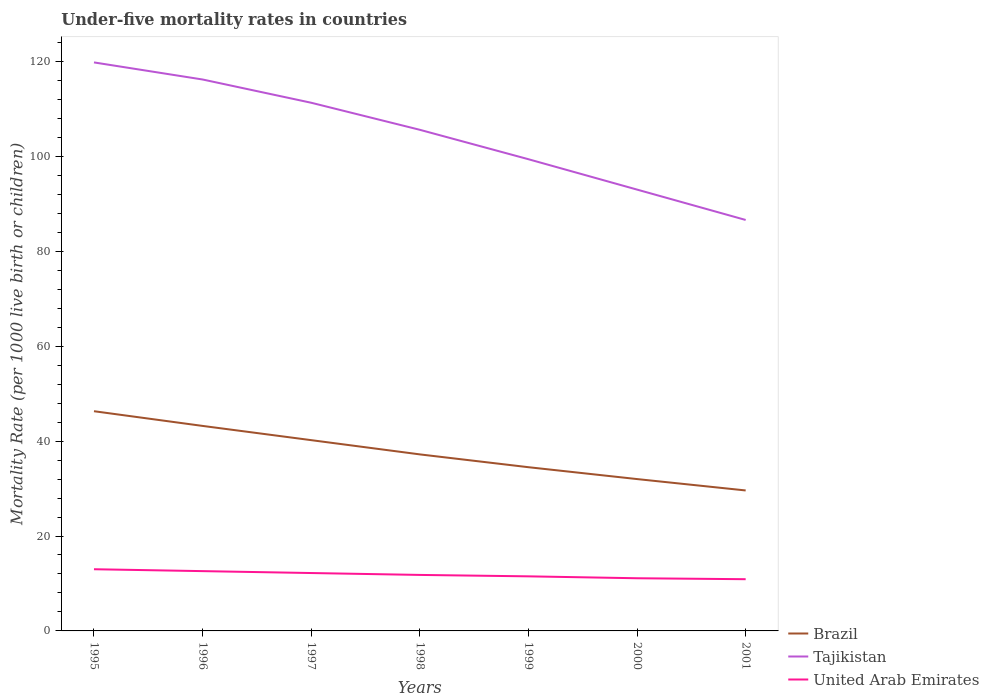Across all years, what is the maximum under-five mortality rate in United Arab Emirates?
Provide a short and direct response. 10.9. What is the total under-five mortality rate in Brazil in the graph?
Provide a succinct answer. 8.7. What is the difference between the highest and the second highest under-five mortality rate in United Arab Emirates?
Your response must be concise. 2.1. What is the difference between the highest and the lowest under-five mortality rate in United Arab Emirates?
Provide a short and direct response. 3. How many years are there in the graph?
Offer a terse response. 7. What is the difference between two consecutive major ticks on the Y-axis?
Offer a terse response. 20. Are the values on the major ticks of Y-axis written in scientific E-notation?
Ensure brevity in your answer.  No. Where does the legend appear in the graph?
Ensure brevity in your answer.  Bottom right. What is the title of the graph?
Ensure brevity in your answer.  Under-five mortality rates in countries. What is the label or title of the Y-axis?
Keep it short and to the point. Mortality Rate (per 1000 live birth or children). What is the Mortality Rate (per 1000 live birth or children) in Brazil in 1995?
Offer a terse response. 46.3. What is the Mortality Rate (per 1000 live birth or children) in Tajikistan in 1995?
Offer a very short reply. 119.8. What is the Mortality Rate (per 1000 live birth or children) of United Arab Emirates in 1995?
Ensure brevity in your answer.  13. What is the Mortality Rate (per 1000 live birth or children) in Brazil in 1996?
Keep it short and to the point. 43.2. What is the Mortality Rate (per 1000 live birth or children) in Tajikistan in 1996?
Ensure brevity in your answer.  116.2. What is the Mortality Rate (per 1000 live birth or children) in United Arab Emirates in 1996?
Provide a short and direct response. 12.6. What is the Mortality Rate (per 1000 live birth or children) of Brazil in 1997?
Your answer should be very brief. 40.2. What is the Mortality Rate (per 1000 live birth or children) of Tajikistan in 1997?
Keep it short and to the point. 111.3. What is the Mortality Rate (per 1000 live birth or children) of United Arab Emirates in 1997?
Your answer should be very brief. 12.2. What is the Mortality Rate (per 1000 live birth or children) of Brazil in 1998?
Provide a succinct answer. 37.2. What is the Mortality Rate (per 1000 live birth or children) of Tajikistan in 1998?
Ensure brevity in your answer.  105.6. What is the Mortality Rate (per 1000 live birth or children) in Brazil in 1999?
Your answer should be compact. 34.5. What is the Mortality Rate (per 1000 live birth or children) in Tajikistan in 1999?
Keep it short and to the point. 99.4. What is the Mortality Rate (per 1000 live birth or children) in United Arab Emirates in 1999?
Your answer should be compact. 11.5. What is the Mortality Rate (per 1000 live birth or children) in Tajikistan in 2000?
Provide a short and direct response. 93. What is the Mortality Rate (per 1000 live birth or children) in Brazil in 2001?
Provide a short and direct response. 29.6. What is the Mortality Rate (per 1000 live birth or children) in Tajikistan in 2001?
Offer a terse response. 86.6. What is the Mortality Rate (per 1000 live birth or children) of United Arab Emirates in 2001?
Ensure brevity in your answer.  10.9. Across all years, what is the maximum Mortality Rate (per 1000 live birth or children) of Brazil?
Ensure brevity in your answer.  46.3. Across all years, what is the maximum Mortality Rate (per 1000 live birth or children) in Tajikistan?
Keep it short and to the point. 119.8. Across all years, what is the maximum Mortality Rate (per 1000 live birth or children) in United Arab Emirates?
Your answer should be very brief. 13. Across all years, what is the minimum Mortality Rate (per 1000 live birth or children) in Brazil?
Give a very brief answer. 29.6. Across all years, what is the minimum Mortality Rate (per 1000 live birth or children) of Tajikistan?
Offer a very short reply. 86.6. Across all years, what is the minimum Mortality Rate (per 1000 live birth or children) in United Arab Emirates?
Offer a very short reply. 10.9. What is the total Mortality Rate (per 1000 live birth or children) in Brazil in the graph?
Your answer should be very brief. 263. What is the total Mortality Rate (per 1000 live birth or children) of Tajikistan in the graph?
Ensure brevity in your answer.  731.9. What is the total Mortality Rate (per 1000 live birth or children) in United Arab Emirates in the graph?
Provide a succinct answer. 83.1. What is the difference between the Mortality Rate (per 1000 live birth or children) in Brazil in 1995 and that in 1996?
Give a very brief answer. 3.1. What is the difference between the Mortality Rate (per 1000 live birth or children) in United Arab Emirates in 1995 and that in 1996?
Make the answer very short. 0.4. What is the difference between the Mortality Rate (per 1000 live birth or children) in United Arab Emirates in 1995 and that in 1997?
Ensure brevity in your answer.  0.8. What is the difference between the Mortality Rate (per 1000 live birth or children) of Brazil in 1995 and that in 1998?
Offer a terse response. 9.1. What is the difference between the Mortality Rate (per 1000 live birth or children) in Brazil in 1995 and that in 1999?
Offer a terse response. 11.8. What is the difference between the Mortality Rate (per 1000 live birth or children) in Tajikistan in 1995 and that in 1999?
Keep it short and to the point. 20.4. What is the difference between the Mortality Rate (per 1000 live birth or children) in United Arab Emirates in 1995 and that in 1999?
Keep it short and to the point. 1.5. What is the difference between the Mortality Rate (per 1000 live birth or children) of Brazil in 1995 and that in 2000?
Provide a succinct answer. 14.3. What is the difference between the Mortality Rate (per 1000 live birth or children) of Tajikistan in 1995 and that in 2000?
Offer a terse response. 26.8. What is the difference between the Mortality Rate (per 1000 live birth or children) of Brazil in 1995 and that in 2001?
Make the answer very short. 16.7. What is the difference between the Mortality Rate (per 1000 live birth or children) of Tajikistan in 1995 and that in 2001?
Offer a very short reply. 33.2. What is the difference between the Mortality Rate (per 1000 live birth or children) in United Arab Emirates in 1995 and that in 2001?
Provide a short and direct response. 2.1. What is the difference between the Mortality Rate (per 1000 live birth or children) in United Arab Emirates in 1996 and that in 1998?
Your response must be concise. 0.8. What is the difference between the Mortality Rate (per 1000 live birth or children) of Brazil in 1996 and that in 1999?
Your answer should be compact. 8.7. What is the difference between the Mortality Rate (per 1000 live birth or children) of Tajikistan in 1996 and that in 1999?
Your response must be concise. 16.8. What is the difference between the Mortality Rate (per 1000 live birth or children) of United Arab Emirates in 1996 and that in 1999?
Provide a short and direct response. 1.1. What is the difference between the Mortality Rate (per 1000 live birth or children) of Tajikistan in 1996 and that in 2000?
Your answer should be very brief. 23.2. What is the difference between the Mortality Rate (per 1000 live birth or children) in Tajikistan in 1996 and that in 2001?
Keep it short and to the point. 29.6. What is the difference between the Mortality Rate (per 1000 live birth or children) in United Arab Emirates in 1997 and that in 1998?
Provide a succinct answer. 0.4. What is the difference between the Mortality Rate (per 1000 live birth or children) in United Arab Emirates in 1997 and that in 1999?
Ensure brevity in your answer.  0.7. What is the difference between the Mortality Rate (per 1000 live birth or children) in Tajikistan in 1997 and that in 2000?
Provide a succinct answer. 18.3. What is the difference between the Mortality Rate (per 1000 live birth or children) of United Arab Emirates in 1997 and that in 2000?
Your answer should be compact. 1.1. What is the difference between the Mortality Rate (per 1000 live birth or children) in Tajikistan in 1997 and that in 2001?
Give a very brief answer. 24.7. What is the difference between the Mortality Rate (per 1000 live birth or children) in United Arab Emirates in 1997 and that in 2001?
Your answer should be very brief. 1.3. What is the difference between the Mortality Rate (per 1000 live birth or children) in Brazil in 1998 and that in 1999?
Your answer should be very brief. 2.7. What is the difference between the Mortality Rate (per 1000 live birth or children) of United Arab Emirates in 1998 and that in 2000?
Provide a short and direct response. 0.7. What is the difference between the Mortality Rate (per 1000 live birth or children) in Tajikistan in 1998 and that in 2001?
Your answer should be very brief. 19. What is the difference between the Mortality Rate (per 1000 live birth or children) of United Arab Emirates in 1998 and that in 2001?
Keep it short and to the point. 0.9. What is the difference between the Mortality Rate (per 1000 live birth or children) of Brazil in 1999 and that in 2000?
Your response must be concise. 2.5. What is the difference between the Mortality Rate (per 1000 live birth or children) in Tajikistan in 1999 and that in 2000?
Offer a terse response. 6.4. What is the difference between the Mortality Rate (per 1000 live birth or children) of United Arab Emirates in 1999 and that in 2000?
Keep it short and to the point. 0.4. What is the difference between the Mortality Rate (per 1000 live birth or children) in Brazil in 1999 and that in 2001?
Make the answer very short. 4.9. What is the difference between the Mortality Rate (per 1000 live birth or children) in Tajikistan in 1999 and that in 2001?
Your response must be concise. 12.8. What is the difference between the Mortality Rate (per 1000 live birth or children) in United Arab Emirates in 1999 and that in 2001?
Keep it short and to the point. 0.6. What is the difference between the Mortality Rate (per 1000 live birth or children) in Tajikistan in 2000 and that in 2001?
Give a very brief answer. 6.4. What is the difference between the Mortality Rate (per 1000 live birth or children) of United Arab Emirates in 2000 and that in 2001?
Offer a very short reply. 0.2. What is the difference between the Mortality Rate (per 1000 live birth or children) of Brazil in 1995 and the Mortality Rate (per 1000 live birth or children) of Tajikistan in 1996?
Provide a succinct answer. -69.9. What is the difference between the Mortality Rate (per 1000 live birth or children) of Brazil in 1995 and the Mortality Rate (per 1000 live birth or children) of United Arab Emirates in 1996?
Provide a succinct answer. 33.7. What is the difference between the Mortality Rate (per 1000 live birth or children) in Tajikistan in 1995 and the Mortality Rate (per 1000 live birth or children) in United Arab Emirates in 1996?
Keep it short and to the point. 107.2. What is the difference between the Mortality Rate (per 1000 live birth or children) of Brazil in 1995 and the Mortality Rate (per 1000 live birth or children) of Tajikistan in 1997?
Make the answer very short. -65. What is the difference between the Mortality Rate (per 1000 live birth or children) in Brazil in 1995 and the Mortality Rate (per 1000 live birth or children) in United Arab Emirates in 1997?
Make the answer very short. 34.1. What is the difference between the Mortality Rate (per 1000 live birth or children) of Tajikistan in 1995 and the Mortality Rate (per 1000 live birth or children) of United Arab Emirates in 1997?
Your response must be concise. 107.6. What is the difference between the Mortality Rate (per 1000 live birth or children) in Brazil in 1995 and the Mortality Rate (per 1000 live birth or children) in Tajikistan in 1998?
Make the answer very short. -59.3. What is the difference between the Mortality Rate (per 1000 live birth or children) of Brazil in 1995 and the Mortality Rate (per 1000 live birth or children) of United Arab Emirates in 1998?
Provide a short and direct response. 34.5. What is the difference between the Mortality Rate (per 1000 live birth or children) of Tajikistan in 1995 and the Mortality Rate (per 1000 live birth or children) of United Arab Emirates in 1998?
Provide a succinct answer. 108. What is the difference between the Mortality Rate (per 1000 live birth or children) in Brazil in 1995 and the Mortality Rate (per 1000 live birth or children) in Tajikistan in 1999?
Make the answer very short. -53.1. What is the difference between the Mortality Rate (per 1000 live birth or children) in Brazil in 1995 and the Mortality Rate (per 1000 live birth or children) in United Arab Emirates in 1999?
Offer a very short reply. 34.8. What is the difference between the Mortality Rate (per 1000 live birth or children) in Tajikistan in 1995 and the Mortality Rate (per 1000 live birth or children) in United Arab Emirates in 1999?
Your response must be concise. 108.3. What is the difference between the Mortality Rate (per 1000 live birth or children) in Brazil in 1995 and the Mortality Rate (per 1000 live birth or children) in Tajikistan in 2000?
Give a very brief answer. -46.7. What is the difference between the Mortality Rate (per 1000 live birth or children) of Brazil in 1995 and the Mortality Rate (per 1000 live birth or children) of United Arab Emirates in 2000?
Offer a terse response. 35.2. What is the difference between the Mortality Rate (per 1000 live birth or children) of Tajikistan in 1995 and the Mortality Rate (per 1000 live birth or children) of United Arab Emirates in 2000?
Ensure brevity in your answer.  108.7. What is the difference between the Mortality Rate (per 1000 live birth or children) of Brazil in 1995 and the Mortality Rate (per 1000 live birth or children) of Tajikistan in 2001?
Keep it short and to the point. -40.3. What is the difference between the Mortality Rate (per 1000 live birth or children) of Brazil in 1995 and the Mortality Rate (per 1000 live birth or children) of United Arab Emirates in 2001?
Your response must be concise. 35.4. What is the difference between the Mortality Rate (per 1000 live birth or children) in Tajikistan in 1995 and the Mortality Rate (per 1000 live birth or children) in United Arab Emirates in 2001?
Make the answer very short. 108.9. What is the difference between the Mortality Rate (per 1000 live birth or children) of Brazil in 1996 and the Mortality Rate (per 1000 live birth or children) of Tajikistan in 1997?
Ensure brevity in your answer.  -68.1. What is the difference between the Mortality Rate (per 1000 live birth or children) of Tajikistan in 1996 and the Mortality Rate (per 1000 live birth or children) of United Arab Emirates in 1997?
Keep it short and to the point. 104. What is the difference between the Mortality Rate (per 1000 live birth or children) in Brazil in 1996 and the Mortality Rate (per 1000 live birth or children) in Tajikistan in 1998?
Provide a short and direct response. -62.4. What is the difference between the Mortality Rate (per 1000 live birth or children) in Brazil in 1996 and the Mortality Rate (per 1000 live birth or children) in United Arab Emirates in 1998?
Offer a terse response. 31.4. What is the difference between the Mortality Rate (per 1000 live birth or children) in Tajikistan in 1996 and the Mortality Rate (per 1000 live birth or children) in United Arab Emirates in 1998?
Your answer should be very brief. 104.4. What is the difference between the Mortality Rate (per 1000 live birth or children) of Brazil in 1996 and the Mortality Rate (per 1000 live birth or children) of Tajikistan in 1999?
Keep it short and to the point. -56.2. What is the difference between the Mortality Rate (per 1000 live birth or children) of Brazil in 1996 and the Mortality Rate (per 1000 live birth or children) of United Arab Emirates in 1999?
Offer a terse response. 31.7. What is the difference between the Mortality Rate (per 1000 live birth or children) in Tajikistan in 1996 and the Mortality Rate (per 1000 live birth or children) in United Arab Emirates in 1999?
Offer a terse response. 104.7. What is the difference between the Mortality Rate (per 1000 live birth or children) in Brazil in 1996 and the Mortality Rate (per 1000 live birth or children) in Tajikistan in 2000?
Give a very brief answer. -49.8. What is the difference between the Mortality Rate (per 1000 live birth or children) in Brazil in 1996 and the Mortality Rate (per 1000 live birth or children) in United Arab Emirates in 2000?
Provide a succinct answer. 32.1. What is the difference between the Mortality Rate (per 1000 live birth or children) of Tajikistan in 1996 and the Mortality Rate (per 1000 live birth or children) of United Arab Emirates in 2000?
Offer a very short reply. 105.1. What is the difference between the Mortality Rate (per 1000 live birth or children) of Brazil in 1996 and the Mortality Rate (per 1000 live birth or children) of Tajikistan in 2001?
Make the answer very short. -43.4. What is the difference between the Mortality Rate (per 1000 live birth or children) in Brazil in 1996 and the Mortality Rate (per 1000 live birth or children) in United Arab Emirates in 2001?
Give a very brief answer. 32.3. What is the difference between the Mortality Rate (per 1000 live birth or children) in Tajikistan in 1996 and the Mortality Rate (per 1000 live birth or children) in United Arab Emirates in 2001?
Provide a succinct answer. 105.3. What is the difference between the Mortality Rate (per 1000 live birth or children) of Brazil in 1997 and the Mortality Rate (per 1000 live birth or children) of Tajikistan in 1998?
Ensure brevity in your answer.  -65.4. What is the difference between the Mortality Rate (per 1000 live birth or children) in Brazil in 1997 and the Mortality Rate (per 1000 live birth or children) in United Arab Emirates in 1998?
Give a very brief answer. 28.4. What is the difference between the Mortality Rate (per 1000 live birth or children) in Tajikistan in 1997 and the Mortality Rate (per 1000 live birth or children) in United Arab Emirates in 1998?
Make the answer very short. 99.5. What is the difference between the Mortality Rate (per 1000 live birth or children) in Brazil in 1997 and the Mortality Rate (per 1000 live birth or children) in Tajikistan in 1999?
Ensure brevity in your answer.  -59.2. What is the difference between the Mortality Rate (per 1000 live birth or children) in Brazil in 1997 and the Mortality Rate (per 1000 live birth or children) in United Arab Emirates in 1999?
Keep it short and to the point. 28.7. What is the difference between the Mortality Rate (per 1000 live birth or children) in Tajikistan in 1997 and the Mortality Rate (per 1000 live birth or children) in United Arab Emirates in 1999?
Your answer should be very brief. 99.8. What is the difference between the Mortality Rate (per 1000 live birth or children) in Brazil in 1997 and the Mortality Rate (per 1000 live birth or children) in Tajikistan in 2000?
Offer a terse response. -52.8. What is the difference between the Mortality Rate (per 1000 live birth or children) in Brazil in 1997 and the Mortality Rate (per 1000 live birth or children) in United Arab Emirates in 2000?
Your answer should be compact. 29.1. What is the difference between the Mortality Rate (per 1000 live birth or children) of Tajikistan in 1997 and the Mortality Rate (per 1000 live birth or children) of United Arab Emirates in 2000?
Your answer should be compact. 100.2. What is the difference between the Mortality Rate (per 1000 live birth or children) of Brazil in 1997 and the Mortality Rate (per 1000 live birth or children) of Tajikistan in 2001?
Give a very brief answer. -46.4. What is the difference between the Mortality Rate (per 1000 live birth or children) of Brazil in 1997 and the Mortality Rate (per 1000 live birth or children) of United Arab Emirates in 2001?
Make the answer very short. 29.3. What is the difference between the Mortality Rate (per 1000 live birth or children) of Tajikistan in 1997 and the Mortality Rate (per 1000 live birth or children) of United Arab Emirates in 2001?
Provide a short and direct response. 100.4. What is the difference between the Mortality Rate (per 1000 live birth or children) of Brazil in 1998 and the Mortality Rate (per 1000 live birth or children) of Tajikistan in 1999?
Give a very brief answer. -62.2. What is the difference between the Mortality Rate (per 1000 live birth or children) in Brazil in 1998 and the Mortality Rate (per 1000 live birth or children) in United Arab Emirates in 1999?
Provide a succinct answer. 25.7. What is the difference between the Mortality Rate (per 1000 live birth or children) of Tajikistan in 1998 and the Mortality Rate (per 1000 live birth or children) of United Arab Emirates in 1999?
Give a very brief answer. 94.1. What is the difference between the Mortality Rate (per 1000 live birth or children) in Brazil in 1998 and the Mortality Rate (per 1000 live birth or children) in Tajikistan in 2000?
Your response must be concise. -55.8. What is the difference between the Mortality Rate (per 1000 live birth or children) of Brazil in 1998 and the Mortality Rate (per 1000 live birth or children) of United Arab Emirates in 2000?
Offer a very short reply. 26.1. What is the difference between the Mortality Rate (per 1000 live birth or children) of Tajikistan in 1998 and the Mortality Rate (per 1000 live birth or children) of United Arab Emirates in 2000?
Offer a very short reply. 94.5. What is the difference between the Mortality Rate (per 1000 live birth or children) in Brazil in 1998 and the Mortality Rate (per 1000 live birth or children) in Tajikistan in 2001?
Ensure brevity in your answer.  -49.4. What is the difference between the Mortality Rate (per 1000 live birth or children) of Brazil in 1998 and the Mortality Rate (per 1000 live birth or children) of United Arab Emirates in 2001?
Keep it short and to the point. 26.3. What is the difference between the Mortality Rate (per 1000 live birth or children) in Tajikistan in 1998 and the Mortality Rate (per 1000 live birth or children) in United Arab Emirates in 2001?
Provide a succinct answer. 94.7. What is the difference between the Mortality Rate (per 1000 live birth or children) in Brazil in 1999 and the Mortality Rate (per 1000 live birth or children) in Tajikistan in 2000?
Ensure brevity in your answer.  -58.5. What is the difference between the Mortality Rate (per 1000 live birth or children) of Brazil in 1999 and the Mortality Rate (per 1000 live birth or children) of United Arab Emirates in 2000?
Provide a short and direct response. 23.4. What is the difference between the Mortality Rate (per 1000 live birth or children) of Tajikistan in 1999 and the Mortality Rate (per 1000 live birth or children) of United Arab Emirates in 2000?
Give a very brief answer. 88.3. What is the difference between the Mortality Rate (per 1000 live birth or children) of Brazil in 1999 and the Mortality Rate (per 1000 live birth or children) of Tajikistan in 2001?
Offer a very short reply. -52.1. What is the difference between the Mortality Rate (per 1000 live birth or children) of Brazil in 1999 and the Mortality Rate (per 1000 live birth or children) of United Arab Emirates in 2001?
Give a very brief answer. 23.6. What is the difference between the Mortality Rate (per 1000 live birth or children) in Tajikistan in 1999 and the Mortality Rate (per 1000 live birth or children) in United Arab Emirates in 2001?
Your answer should be compact. 88.5. What is the difference between the Mortality Rate (per 1000 live birth or children) in Brazil in 2000 and the Mortality Rate (per 1000 live birth or children) in Tajikistan in 2001?
Offer a terse response. -54.6. What is the difference between the Mortality Rate (per 1000 live birth or children) of Brazil in 2000 and the Mortality Rate (per 1000 live birth or children) of United Arab Emirates in 2001?
Make the answer very short. 21.1. What is the difference between the Mortality Rate (per 1000 live birth or children) in Tajikistan in 2000 and the Mortality Rate (per 1000 live birth or children) in United Arab Emirates in 2001?
Provide a succinct answer. 82.1. What is the average Mortality Rate (per 1000 live birth or children) of Brazil per year?
Your answer should be compact. 37.57. What is the average Mortality Rate (per 1000 live birth or children) in Tajikistan per year?
Offer a terse response. 104.56. What is the average Mortality Rate (per 1000 live birth or children) in United Arab Emirates per year?
Your answer should be compact. 11.87. In the year 1995, what is the difference between the Mortality Rate (per 1000 live birth or children) of Brazil and Mortality Rate (per 1000 live birth or children) of Tajikistan?
Give a very brief answer. -73.5. In the year 1995, what is the difference between the Mortality Rate (per 1000 live birth or children) in Brazil and Mortality Rate (per 1000 live birth or children) in United Arab Emirates?
Offer a terse response. 33.3. In the year 1995, what is the difference between the Mortality Rate (per 1000 live birth or children) in Tajikistan and Mortality Rate (per 1000 live birth or children) in United Arab Emirates?
Ensure brevity in your answer.  106.8. In the year 1996, what is the difference between the Mortality Rate (per 1000 live birth or children) in Brazil and Mortality Rate (per 1000 live birth or children) in Tajikistan?
Ensure brevity in your answer.  -73. In the year 1996, what is the difference between the Mortality Rate (per 1000 live birth or children) in Brazil and Mortality Rate (per 1000 live birth or children) in United Arab Emirates?
Keep it short and to the point. 30.6. In the year 1996, what is the difference between the Mortality Rate (per 1000 live birth or children) in Tajikistan and Mortality Rate (per 1000 live birth or children) in United Arab Emirates?
Ensure brevity in your answer.  103.6. In the year 1997, what is the difference between the Mortality Rate (per 1000 live birth or children) in Brazil and Mortality Rate (per 1000 live birth or children) in Tajikistan?
Provide a succinct answer. -71.1. In the year 1997, what is the difference between the Mortality Rate (per 1000 live birth or children) of Tajikistan and Mortality Rate (per 1000 live birth or children) of United Arab Emirates?
Make the answer very short. 99.1. In the year 1998, what is the difference between the Mortality Rate (per 1000 live birth or children) in Brazil and Mortality Rate (per 1000 live birth or children) in Tajikistan?
Provide a succinct answer. -68.4. In the year 1998, what is the difference between the Mortality Rate (per 1000 live birth or children) in Brazil and Mortality Rate (per 1000 live birth or children) in United Arab Emirates?
Keep it short and to the point. 25.4. In the year 1998, what is the difference between the Mortality Rate (per 1000 live birth or children) of Tajikistan and Mortality Rate (per 1000 live birth or children) of United Arab Emirates?
Offer a very short reply. 93.8. In the year 1999, what is the difference between the Mortality Rate (per 1000 live birth or children) in Brazil and Mortality Rate (per 1000 live birth or children) in Tajikistan?
Provide a short and direct response. -64.9. In the year 1999, what is the difference between the Mortality Rate (per 1000 live birth or children) of Tajikistan and Mortality Rate (per 1000 live birth or children) of United Arab Emirates?
Provide a short and direct response. 87.9. In the year 2000, what is the difference between the Mortality Rate (per 1000 live birth or children) of Brazil and Mortality Rate (per 1000 live birth or children) of Tajikistan?
Provide a succinct answer. -61. In the year 2000, what is the difference between the Mortality Rate (per 1000 live birth or children) in Brazil and Mortality Rate (per 1000 live birth or children) in United Arab Emirates?
Keep it short and to the point. 20.9. In the year 2000, what is the difference between the Mortality Rate (per 1000 live birth or children) of Tajikistan and Mortality Rate (per 1000 live birth or children) of United Arab Emirates?
Make the answer very short. 81.9. In the year 2001, what is the difference between the Mortality Rate (per 1000 live birth or children) in Brazil and Mortality Rate (per 1000 live birth or children) in Tajikistan?
Make the answer very short. -57. In the year 2001, what is the difference between the Mortality Rate (per 1000 live birth or children) of Tajikistan and Mortality Rate (per 1000 live birth or children) of United Arab Emirates?
Provide a succinct answer. 75.7. What is the ratio of the Mortality Rate (per 1000 live birth or children) of Brazil in 1995 to that in 1996?
Make the answer very short. 1.07. What is the ratio of the Mortality Rate (per 1000 live birth or children) in Tajikistan in 1995 to that in 1996?
Offer a very short reply. 1.03. What is the ratio of the Mortality Rate (per 1000 live birth or children) in United Arab Emirates in 1995 to that in 1996?
Provide a succinct answer. 1.03. What is the ratio of the Mortality Rate (per 1000 live birth or children) in Brazil in 1995 to that in 1997?
Offer a very short reply. 1.15. What is the ratio of the Mortality Rate (per 1000 live birth or children) of Tajikistan in 1995 to that in 1997?
Your answer should be compact. 1.08. What is the ratio of the Mortality Rate (per 1000 live birth or children) in United Arab Emirates in 1995 to that in 1997?
Give a very brief answer. 1.07. What is the ratio of the Mortality Rate (per 1000 live birth or children) in Brazil in 1995 to that in 1998?
Ensure brevity in your answer.  1.24. What is the ratio of the Mortality Rate (per 1000 live birth or children) of Tajikistan in 1995 to that in 1998?
Keep it short and to the point. 1.13. What is the ratio of the Mortality Rate (per 1000 live birth or children) of United Arab Emirates in 1995 to that in 1998?
Your answer should be very brief. 1.1. What is the ratio of the Mortality Rate (per 1000 live birth or children) in Brazil in 1995 to that in 1999?
Ensure brevity in your answer.  1.34. What is the ratio of the Mortality Rate (per 1000 live birth or children) in Tajikistan in 1995 to that in 1999?
Your answer should be compact. 1.21. What is the ratio of the Mortality Rate (per 1000 live birth or children) in United Arab Emirates in 1995 to that in 1999?
Provide a succinct answer. 1.13. What is the ratio of the Mortality Rate (per 1000 live birth or children) of Brazil in 1995 to that in 2000?
Ensure brevity in your answer.  1.45. What is the ratio of the Mortality Rate (per 1000 live birth or children) in Tajikistan in 1995 to that in 2000?
Ensure brevity in your answer.  1.29. What is the ratio of the Mortality Rate (per 1000 live birth or children) of United Arab Emirates in 1995 to that in 2000?
Ensure brevity in your answer.  1.17. What is the ratio of the Mortality Rate (per 1000 live birth or children) of Brazil in 1995 to that in 2001?
Keep it short and to the point. 1.56. What is the ratio of the Mortality Rate (per 1000 live birth or children) in Tajikistan in 1995 to that in 2001?
Make the answer very short. 1.38. What is the ratio of the Mortality Rate (per 1000 live birth or children) in United Arab Emirates in 1995 to that in 2001?
Offer a very short reply. 1.19. What is the ratio of the Mortality Rate (per 1000 live birth or children) in Brazil in 1996 to that in 1997?
Offer a terse response. 1.07. What is the ratio of the Mortality Rate (per 1000 live birth or children) in Tajikistan in 1996 to that in 1997?
Offer a terse response. 1.04. What is the ratio of the Mortality Rate (per 1000 live birth or children) of United Arab Emirates in 1996 to that in 1997?
Give a very brief answer. 1.03. What is the ratio of the Mortality Rate (per 1000 live birth or children) of Brazil in 1996 to that in 1998?
Ensure brevity in your answer.  1.16. What is the ratio of the Mortality Rate (per 1000 live birth or children) in Tajikistan in 1996 to that in 1998?
Offer a terse response. 1.1. What is the ratio of the Mortality Rate (per 1000 live birth or children) in United Arab Emirates in 1996 to that in 1998?
Provide a succinct answer. 1.07. What is the ratio of the Mortality Rate (per 1000 live birth or children) in Brazil in 1996 to that in 1999?
Provide a succinct answer. 1.25. What is the ratio of the Mortality Rate (per 1000 live birth or children) in Tajikistan in 1996 to that in 1999?
Offer a terse response. 1.17. What is the ratio of the Mortality Rate (per 1000 live birth or children) of United Arab Emirates in 1996 to that in 1999?
Your answer should be compact. 1.1. What is the ratio of the Mortality Rate (per 1000 live birth or children) in Brazil in 1996 to that in 2000?
Offer a very short reply. 1.35. What is the ratio of the Mortality Rate (per 1000 live birth or children) in Tajikistan in 1996 to that in 2000?
Your response must be concise. 1.25. What is the ratio of the Mortality Rate (per 1000 live birth or children) in United Arab Emirates in 1996 to that in 2000?
Keep it short and to the point. 1.14. What is the ratio of the Mortality Rate (per 1000 live birth or children) in Brazil in 1996 to that in 2001?
Offer a terse response. 1.46. What is the ratio of the Mortality Rate (per 1000 live birth or children) in Tajikistan in 1996 to that in 2001?
Provide a short and direct response. 1.34. What is the ratio of the Mortality Rate (per 1000 live birth or children) of United Arab Emirates in 1996 to that in 2001?
Keep it short and to the point. 1.16. What is the ratio of the Mortality Rate (per 1000 live birth or children) of Brazil in 1997 to that in 1998?
Keep it short and to the point. 1.08. What is the ratio of the Mortality Rate (per 1000 live birth or children) of Tajikistan in 1997 to that in 1998?
Keep it short and to the point. 1.05. What is the ratio of the Mortality Rate (per 1000 live birth or children) of United Arab Emirates in 1997 to that in 1998?
Your answer should be compact. 1.03. What is the ratio of the Mortality Rate (per 1000 live birth or children) of Brazil in 1997 to that in 1999?
Your answer should be compact. 1.17. What is the ratio of the Mortality Rate (per 1000 live birth or children) of Tajikistan in 1997 to that in 1999?
Make the answer very short. 1.12. What is the ratio of the Mortality Rate (per 1000 live birth or children) in United Arab Emirates in 1997 to that in 1999?
Your response must be concise. 1.06. What is the ratio of the Mortality Rate (per 1000 live birth or children) in Brazil in 1997 to that in 2000?
Provide a short and direct response. 1.26. What is the ratio of the Mortality Rate (per 1000 live birth or children) in Tajikistan in 1997 to that in 2000?
Offer a very short reply. 1.2. What is the ratio of the Mortality Rate (per 1000 live birth or children) of United Arab Emirates in 1997 to that in 2000?
Ensure brevity in your answer.  1.1. What is the ratio of the Mortality Rate (per 1000 live birth or children) of Brazil in 1997 to that in 2001?
Give a very brief answer. 1.36. What is the ratio of the Mortality Rate (per 1000 live birth or children) in Tajikistan in 1997 to that in 2001?
Keep it short and to the point. 1.29. What is the ratio of the Mortality Rate (per 1000 live birth or children) in United Arab Emirates in 1997 to that in 2001?
Keep it short and to the point. 1.12. What is the ratio of the Mortality Rate (per 1000 live birth or children) in Brazil in 1998 to that in 1999?
Your answer should be compact. 1.08. What is the ratio of the Mortality Rate (per 1000 live birth or children) in Tajikistan in 1998 to that in 1999?
Make the answer very short. 1.06. What is the ratio of the Mortality Rate (per 1000 live birth or children) in United Arab Emirates in 1998 to that in 1999?
Offer a terse response. 1.03. What is the ratio of the Mortality Rate (per 1000 live birth or children) of Brazil in 1998 to that in 2000?
Your answer should be very brief. 1.16. What is the ratio of the Mortality Rate (per 1000 live birth or children) in Tajikistan in 1998 to that in 2000?
Provide a succinct answer. 1.14. What is the ratio of the Mortality Rate (per 1000 live birth or children) in United Arab Emirates in 1998 to that in 2000?
Provide a short and direct response. 1.06. What is the ratio of the Mortality Rate (per 1000 live birth or children) of Brazil in 1998 to that in 2001?
Your answer should be compact. 1.26. What is the ratio of the Mortality Rate (per 1000 live birth or children) in Tajikistan in 1998 to that in 2001?
Give a very brief answer. 1.22. What is the ratio of the Mortality Rate (per 1000 live birth or children) of United Arab Emirates in 1998 to that in 2001?
Offer a terse response. 1.08. What is the ratio of the Mortality Rate (per 1000 live birth or children) of Brazil in 1999 to that in 2000?
Provide a succinct answer. 1.08. What is the ratio of the Mortality Rate (per 1000 live birth or children) in Tajikistan in 1999 to that in 2000?
Your answer should be very brief. 1.07. What is the ratio of the Mortality Rate (per 1000 live birth or children) in United Arab Emirates in 1999 to that in 2000?
Give a very brief answer. 1.04. What is the ratio of the Mortality Rate (per 1000 live birth or children) in Brazil in 1999 to that in 2001?
Offer a very short reply. 1.17. What is the ratio of the Mortality Rate (per 1000 live birth or children) of Tajikistan in 1999 to that in 2001?
Offer a very short reply. 1.15. What is the ratio of the Mortality Rate (per 1000 live birth or children) of United Arab Emirates in 1999 to that in 2001?
Provide a short and direct response. 1.05. What is the ratio of the Mortality Rate (per 1000 live birth or children) in Brazil in 2000 to that in 2001?
Your response must be concise. 1.08. What is the ratio of the Mortality Rate (per 1000 live birth or children) in Tajikistan in 2000 to that in 2001?
Provide a succinct answer. 1.07. What is the ratio of the Mortality Rate (per 1000 live birth or children) of United Arab Emirates in 2000 to that in 2001?
Your response must be concise. 1.02. What is the difference between the highest and the second highest Mortality Rate (per 1000 live birth or children) of Brazil?
Give a very brief answer. 3.1. What is the difference between the highest and the lowest Mortality Rate (per 1000 live birth or children) in Tajikistan?
Give a very brief answer. 33.2. What is the difference between the highest and the lowest Mortality Rate (per 1000 live birth or children) of United Arab Emirates?
Your answer should be compact. 2.1. 